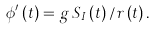<formula> <loc_0><loc_0><loc_500><loc_500>\phi ^ { \prime } \left ( t \right ) = g \, S _ { I } \left ( t \right ) / r \left ( t \right ) .</formula> 